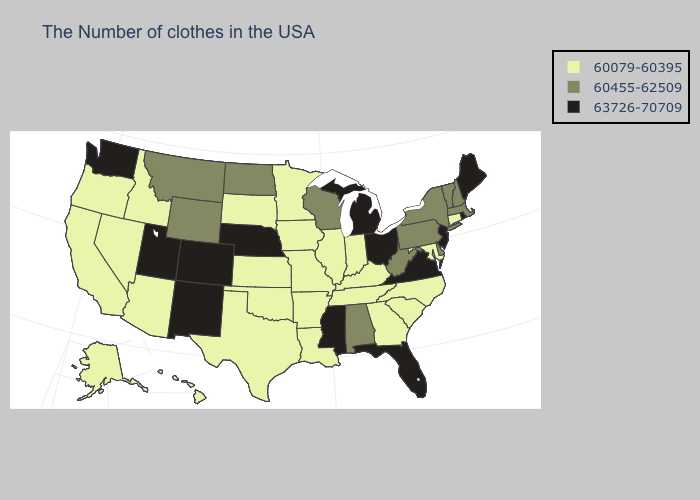Does Wyoming have a higher value than Massachusetts?
Concise answer only. No. Among the states that border Nevada , which have the highest value?
Keep it brief. Utah. Which states have the lowest value in the USA?
Be succinct. Connecticut, Maryland, North Carolina, South Carolina, Georgia, Kentucky, Indiana, Tennessee, Illinois, Louisiana, Missouri, Arkansas, Minnesota, Iowa, Kansas, Oklahoma, Texas, South Dakota, Arizona, Idaho, Nevada, California, Oregon, Alaska, Hawaii. Name the states that have a value in the range 60455-62509?
Concise answer only. Massachusetts, New Hampshire, Vermont, New York, Delaware, Pennsylvania, West Virginia, Alabama, Wisconsin, North Dakota, Wyoming, Montana. Among the states that border Missouri , which have the highest value?
Quick response, please. Nebraska. Which states hav the highest value in the MidWest?
Answer briefly. Ohio, Michigan, Nebraska. What is the value of Wisconsin?
Give a very brief answer. 60455-62509. What is the highest value in the Northeast ?
Short answer required. 63726-70709. Does the first symbol in the legend represent the smallest category?
Be succinct. Yes. Name the states that have a value in the range 63726-70709?
Concise answer only. Maine, Rhode Island, New Jersey, Virginia, Ohio, Florida, Michigan, Mississippi, Nebraska, Colorado, New Mexico, Utah, Washington. What is the highest value in states that border Louisiana?
Be succinct. 63726-70709. What is the value of Oklahoma?
Keep it brief. 60079-60395. Does Maine have the highest value in the USA?
Write a very short answer. Yes. Name the states that have a value in the range 63726-70709?
Short answer required. Maine, Rhode Island, New Jersey, Virginia, Ohio, Florida, Michigan, Mississippi, Nebraska, Colorado, New Mexico, Utah, Washington. Among the states that border Virginia , does West Virginia have the highest value?
Be succinct. Yes. 